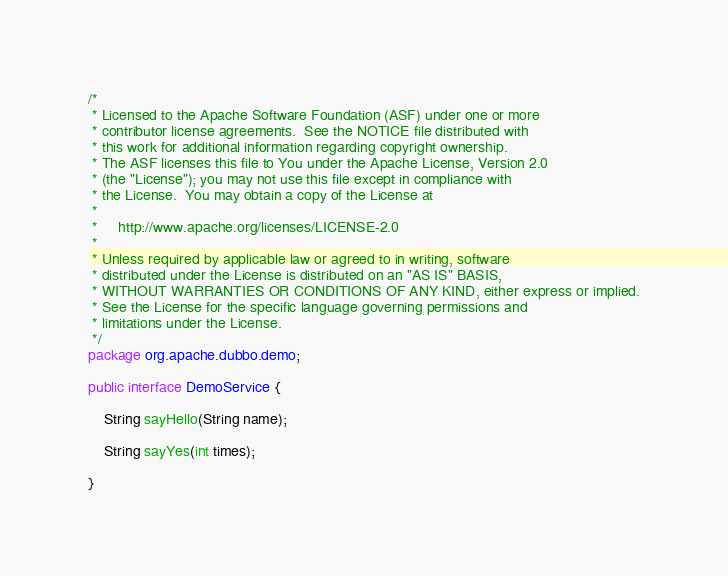Convert code to text. <code><loc_0><loc_0><loc_500><loc_500><_Java_>/*
 * Licensed to the Apache Software Foundation (ASF) under one or more
 * contributor license agreements.  See the NOTICE file distributed with
 * this work for additional information regarding copyright ownership.
 * The ASF licenses this file to You under the Apache License, Version 2.0
 * (the "License"); you may not use this file except in compliance with
 * the License.  You may obtain a copy of the License at
 *
 *     http://www.apache.org/licenses/LICENSE-2.0
 *
 * Unless required by applicable law or agreed to in writing, software
 * distributed under the License is distributed on an "AS IS" BASIS,
 * WITHOUT WARRANTIES OR CONDITIONS OF ANY KIND, either express or implied.
 * See the License for the specific language governing permissions and
 * limitations under the License.
 */
package org.apache.dubbo.demo;

public interface DemoService {

    String sayHello(String name);

    String sayYes(int times);

}</code> 